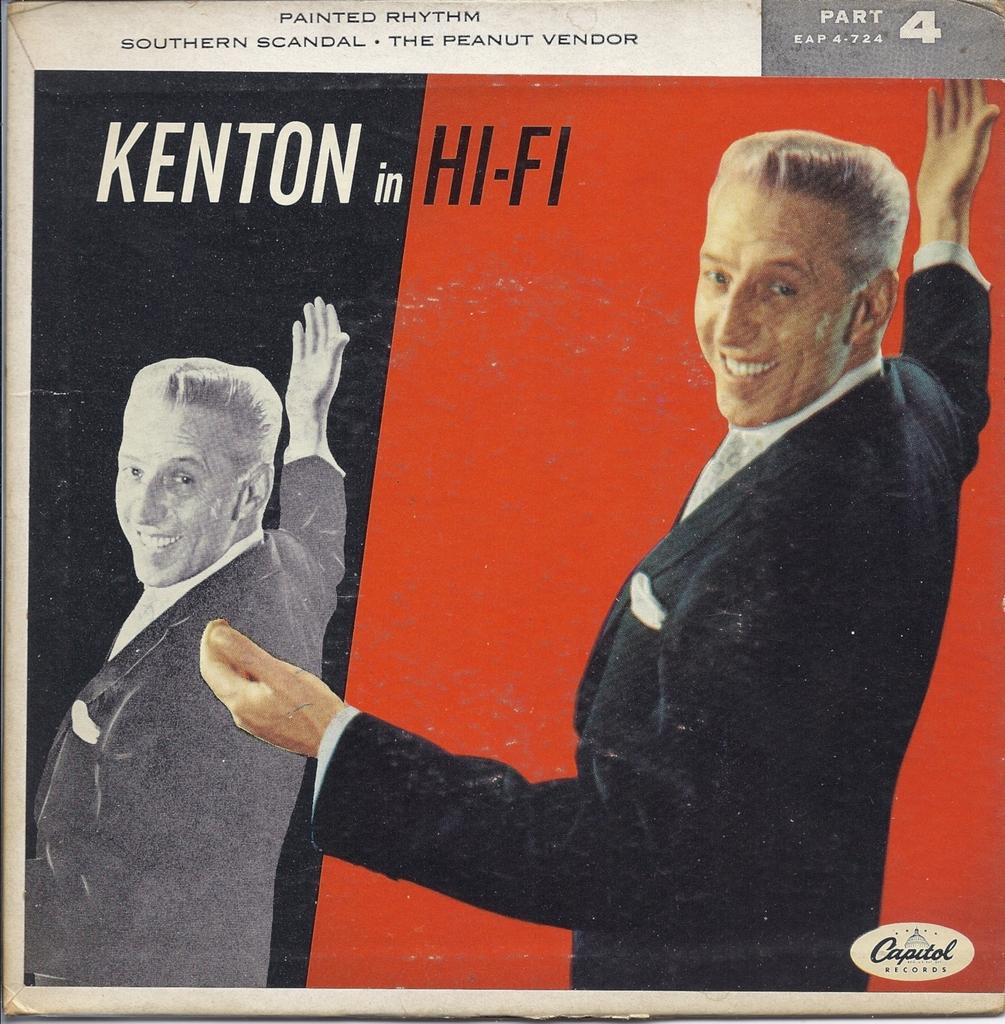What is featured on the poster in the image? There is a poster in the image, and it contains a picture of a man. What else can be seen on the poster besides the picture of the man? There is text on the poster. Can you tell me how many houses are depicted on the poster? There are no houses depicted on the poster; it features a picture of a man and text. Is the man in the poster driving a vehicle? There is no indication of a vehicle or driving in the image; it only shows a poster with a picture of a man and text. 